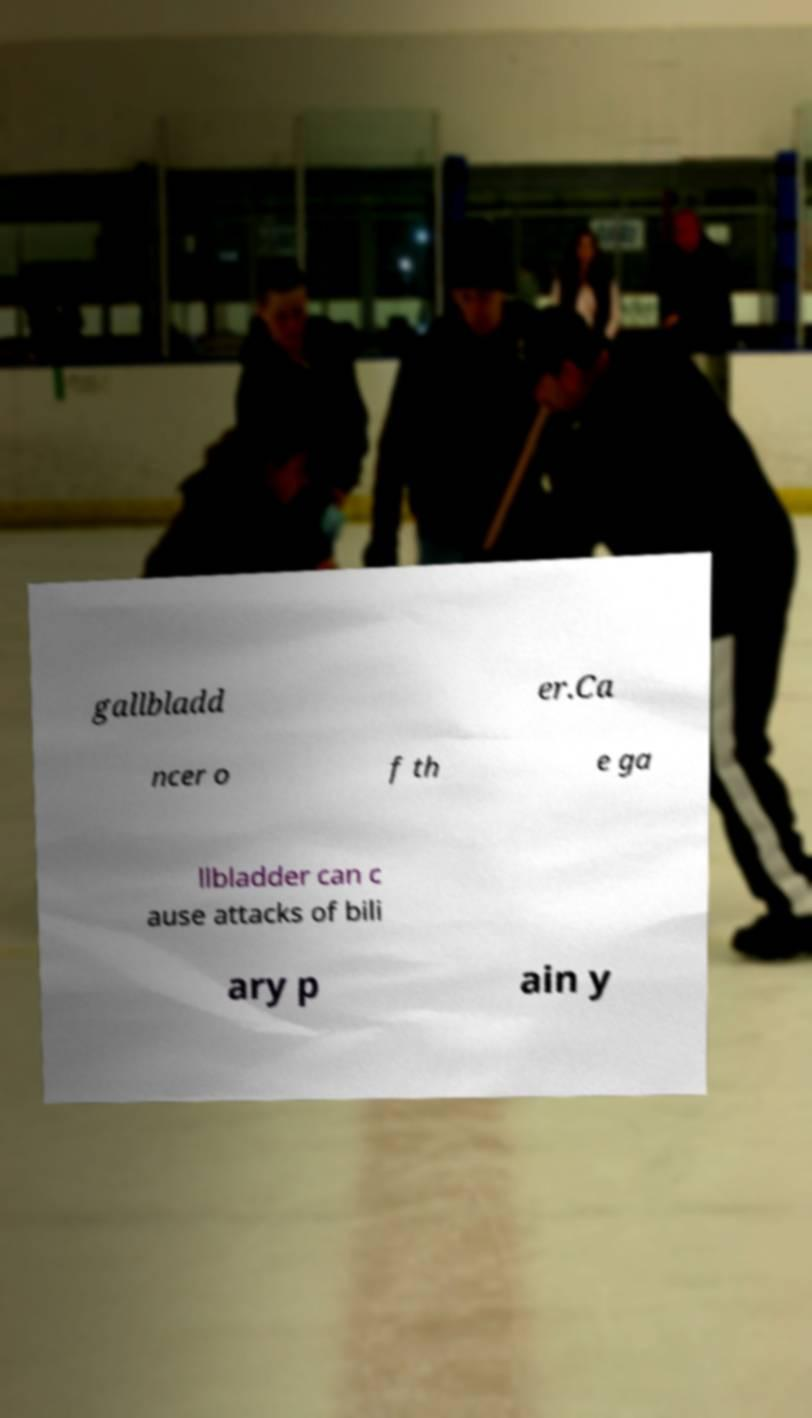Could you extract and type out the text from this image? gallbladd er.Ca ncer o f th e ga llbladder can c ause attacks of bili ary p ain y 